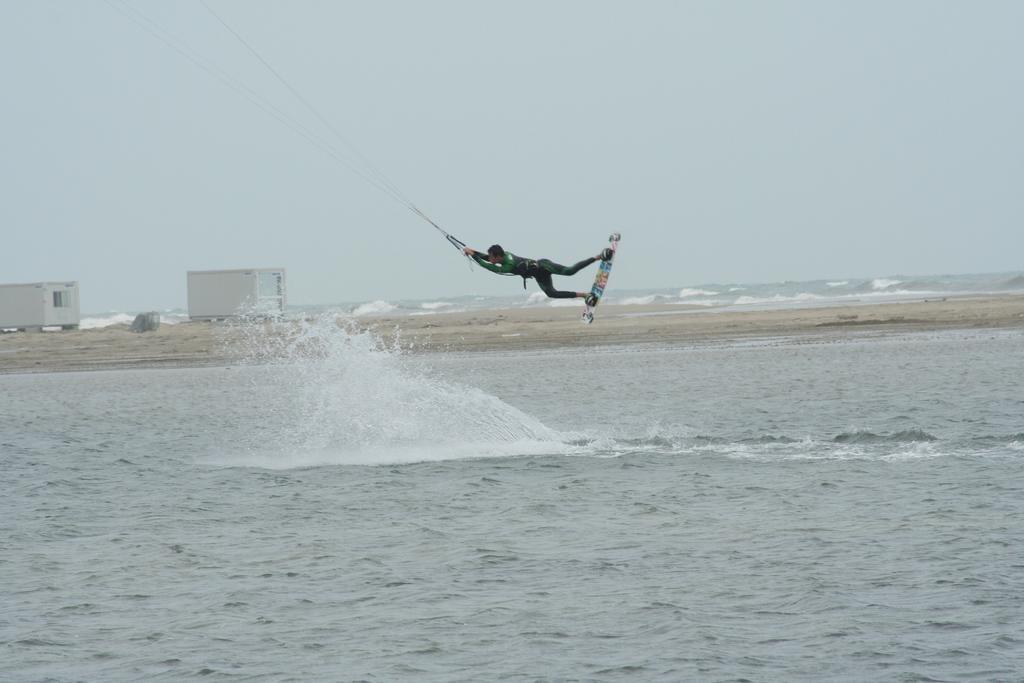Could you give a brief overview of what you see in this image? In this image I can see a person in air. The person is holding a rope and the person is wearing a surfboard. In the background I can see few objects in white color and the sky is in white color. 